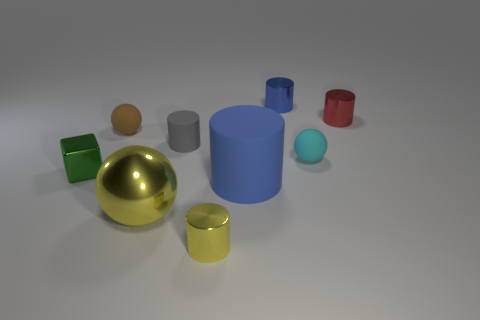Subtract all matte cylinders. How many cylinders are left? 3 Subtract 2 cylinders. How many cylinders are left? 3 Subtract all gray cylinders. How many cylinders are left? 4 Add 1 small rubber balls. How many objects exist? 10 Subtract all gray cylinders. Subtract all red spheres. How many cylinders are left? 4 Subtract all blocks. How many objects are left? 8 Add 4 yellow metallic cylinders. How many yellow metallic cylinders are left? 5 Add 9 large metallic things. How many large metallic things exist? 10 Subtract 0 gray balls. How many objects are left? 9 Subtract all big matte cylinders. Subtract all big blue matte cylinders. How many objects are left? 7 